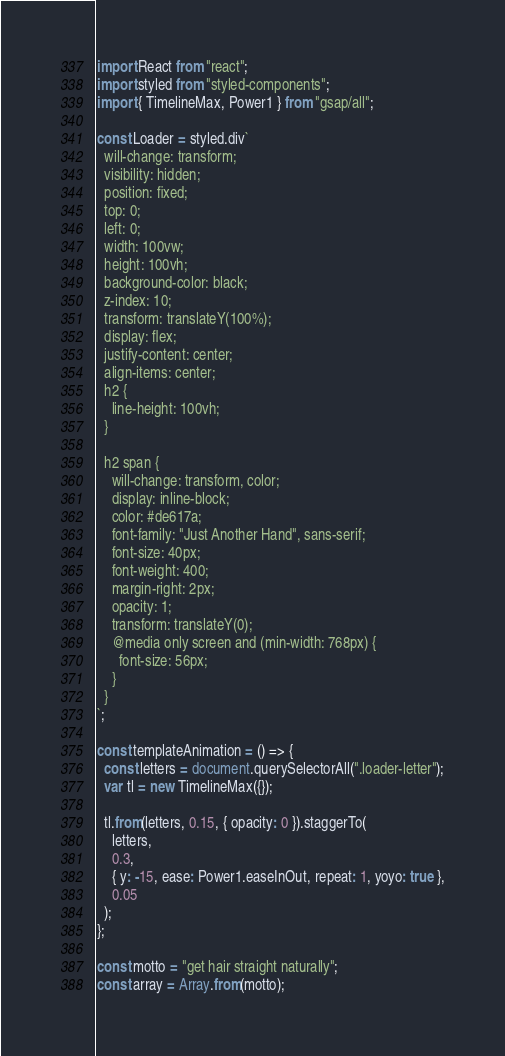Convert code to text. <code><loc_0><loc_0><loc_500><loc_500><_JavaScript_>import React from "react";
import styled from "styled-components";
import { TimelineMax, Power1 } from "gsap/all";

const Loader = styled.div`
  will-change: transform;
  visibility: hidden;
  position: fixed;
  top: 0;
  left: 0;
  width: 100vw;
  height: 100vh;
  background-color: black;
  z-index: 10;
  transform: translateY(100%);
  display: flex;
  justify-content: center;
  align-items: center;
  h2 {
    line-height: 100vh;
  }

  h2 span {
    will-change: transform, color;
    display: inline-block;
    color: #de617a;
    font-family: "Just Another Hand", sans-serif;
    font-size: 40px;
    font-weight: 400;
    margin-right: 2px;
    opacity: 1;
    transform: translateY(0);
    @media only screen and (min-width: 768px) {
      font-size: 56px;
    }
  }
`;

const templateAnimation = () => {
  const letters = document.querySelectorAll(".loader-letter");
  var tl = new TimelineMax({});

  tl.from(letters, 0.15, { opacity: 0 }).staggerTo(
    letters,
    0.3,
    { y: -15, ease: Power1.easeInOut, repeat: 1, yoyo: true },
    0.05
  );
};

const motto = "get hair straight naturally";
const array = Array.from(motto);</code> 